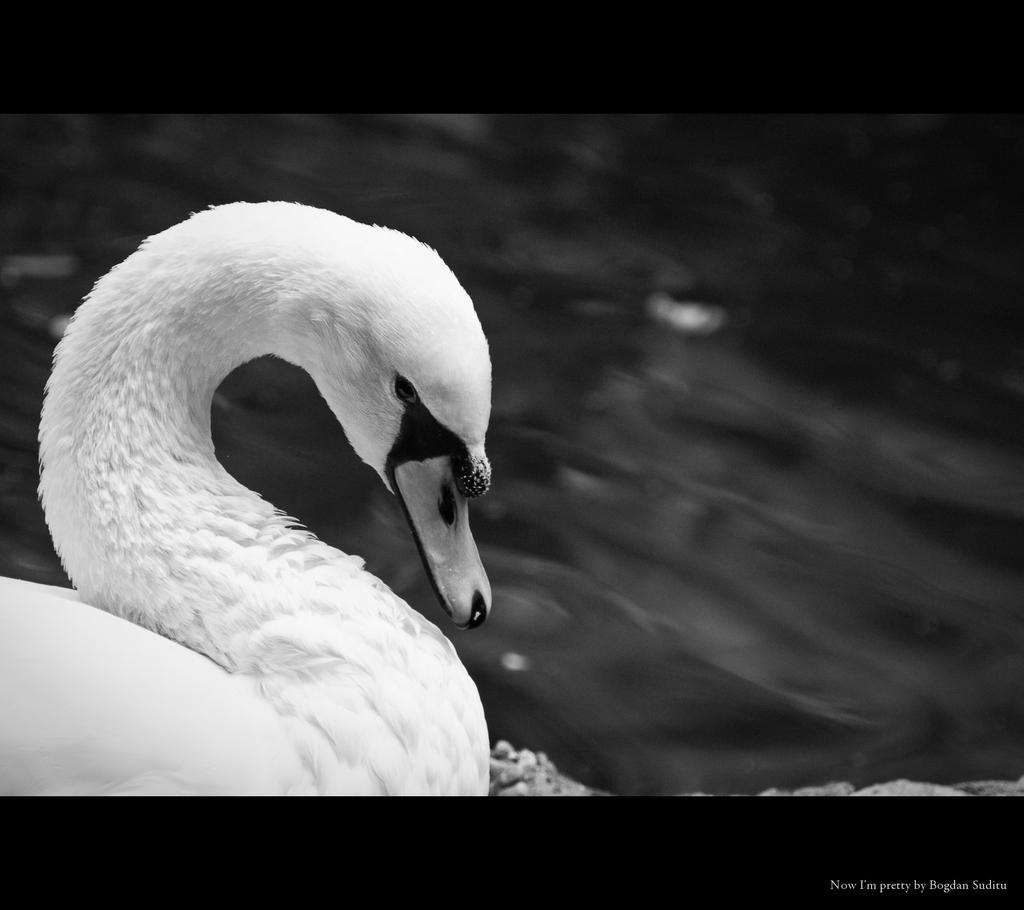What type of animal can be seen in the image? There is a bird in the image. What color is the bird? The bird is white in color. How is the bird positioned in the image? The bird is blurred in the background. Is there any additional information or markings in the image? Yes, there is a watermark in the right bottom corner of the image. What type of anger is the bird displaying in the image? There is no indication of anger in the image; the bird is simply blurred in the background. Can you see any dinosaurs in the image? No, there are no dinosaurs present in the image. 